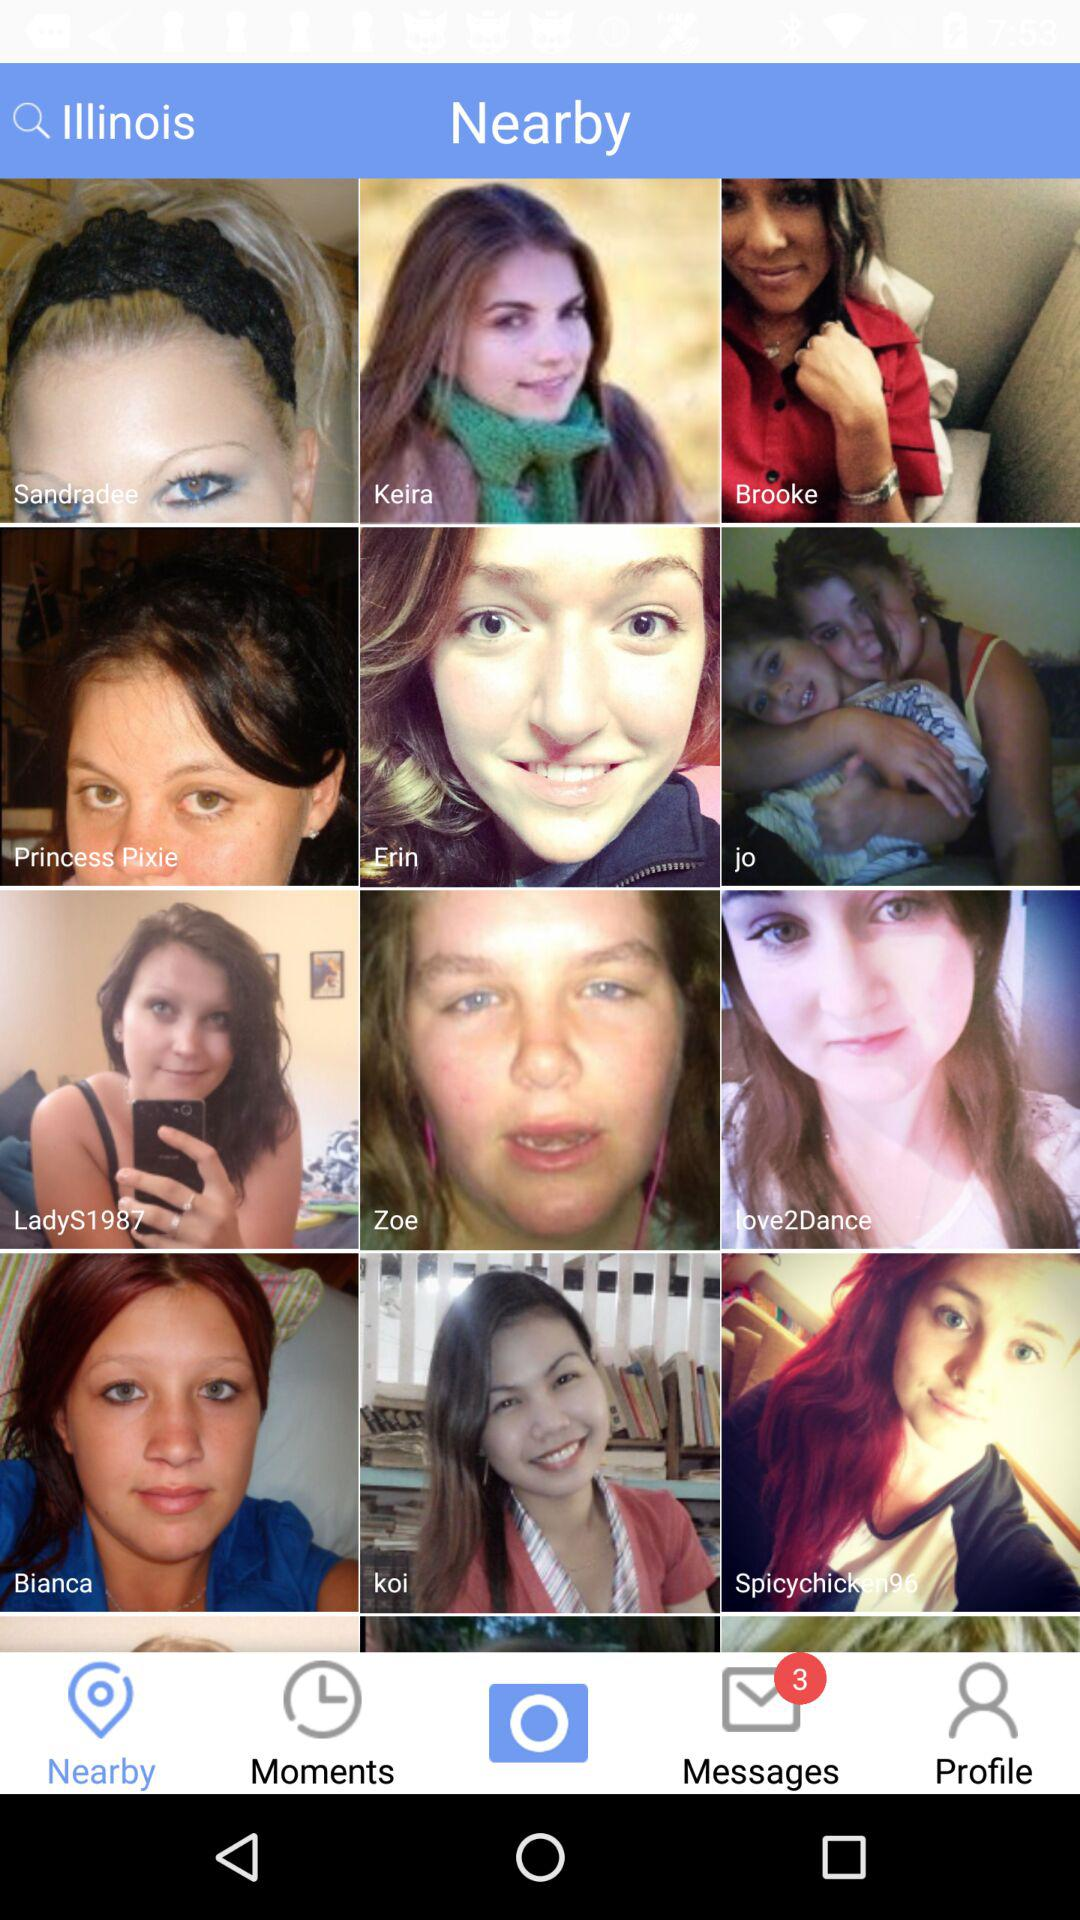What is the location? The location is Illinois. 